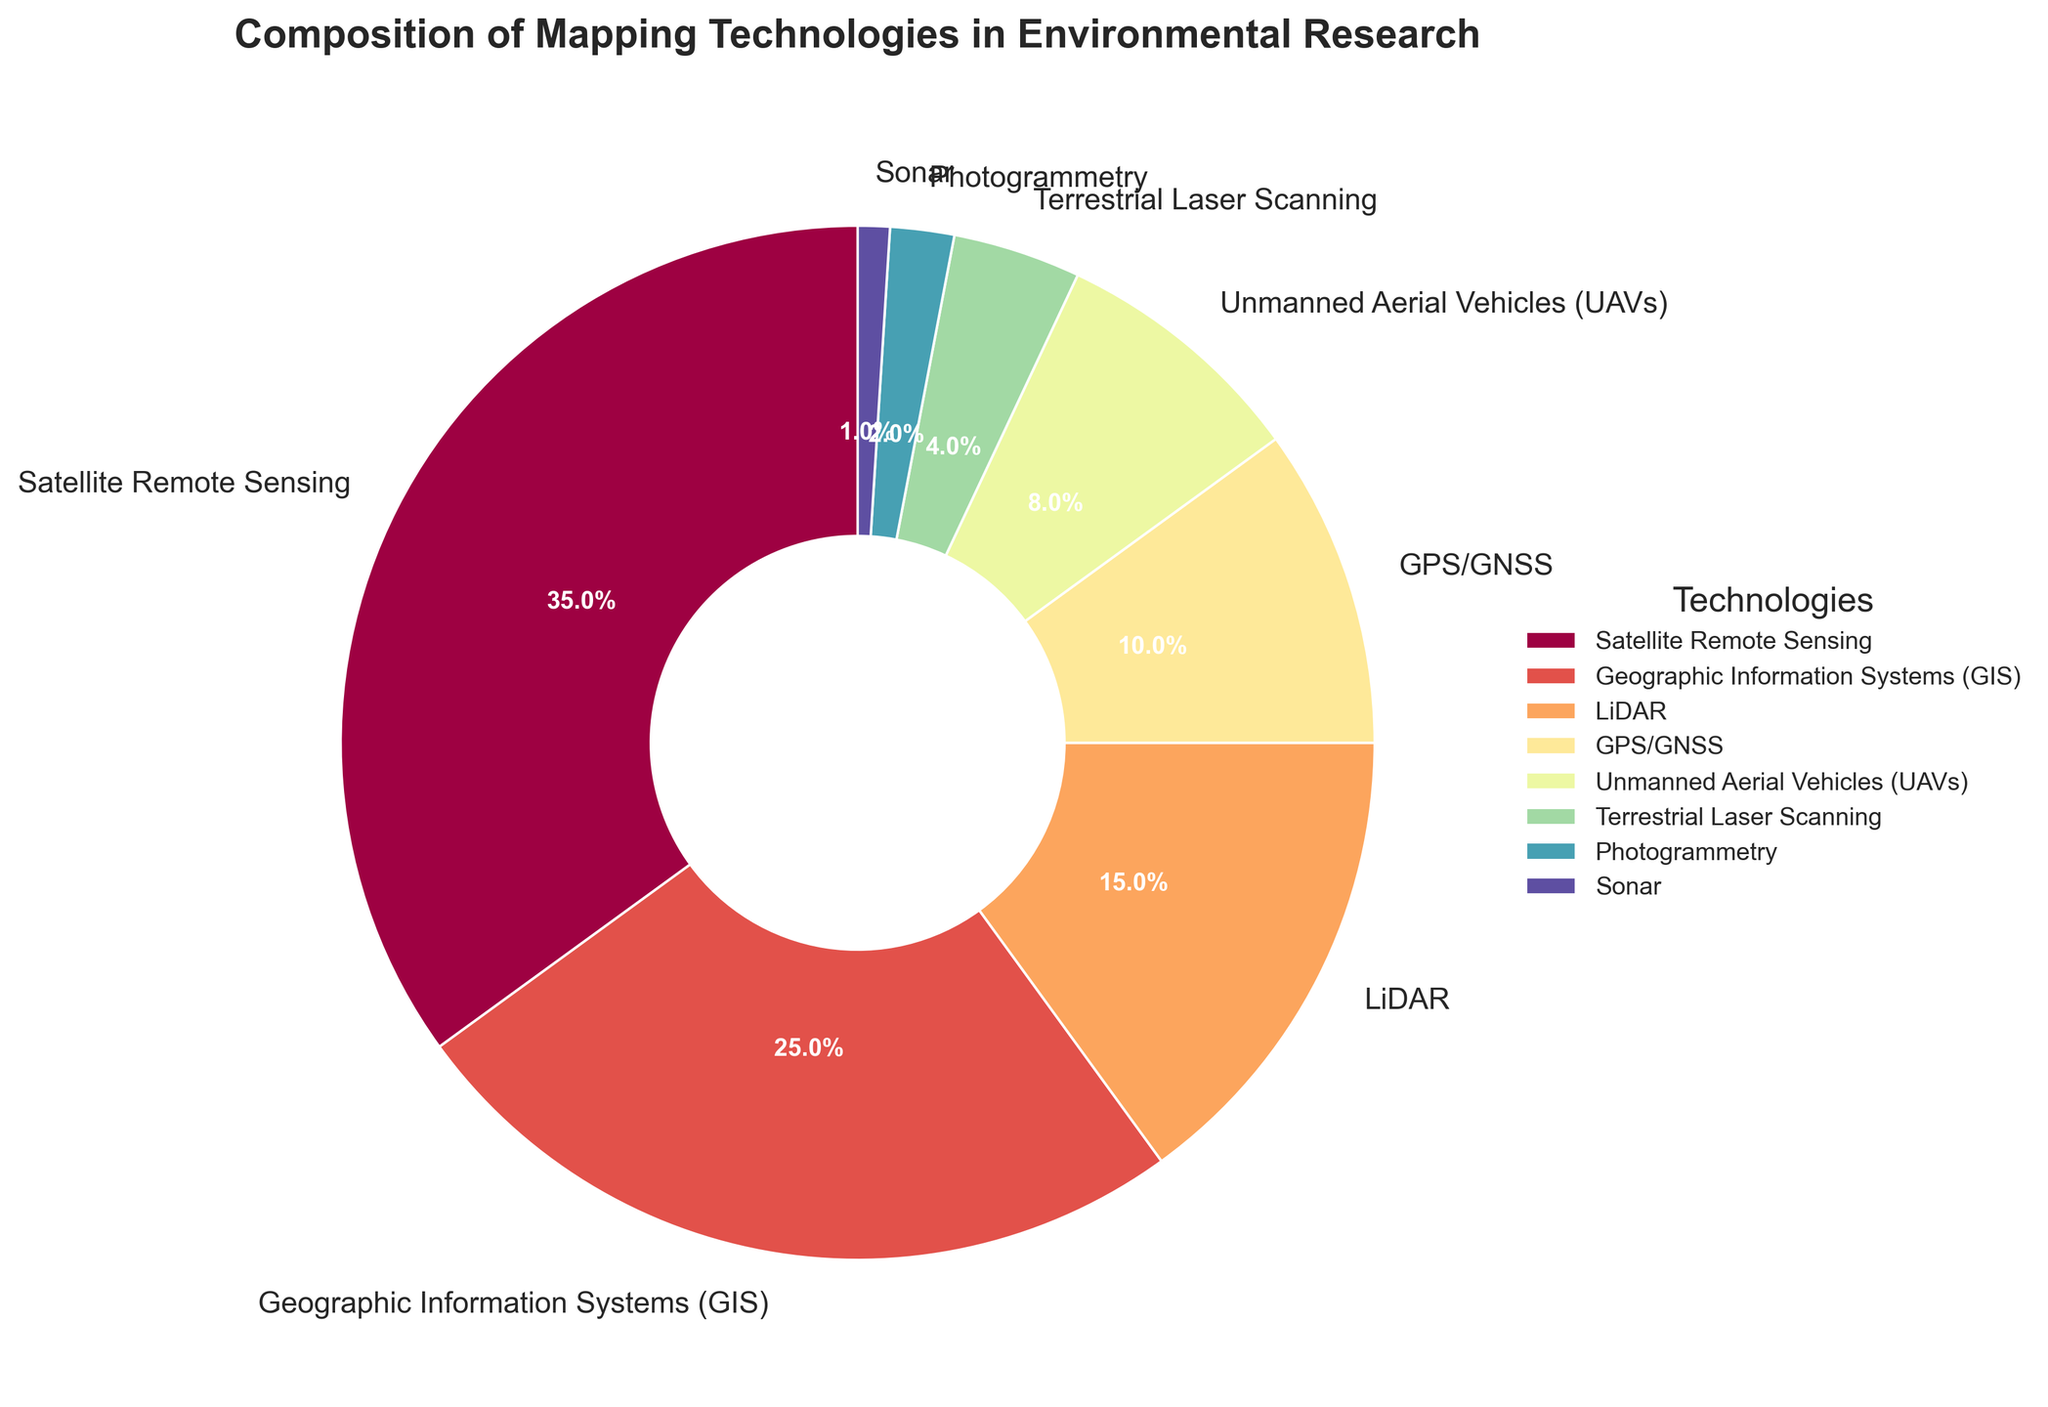What's the sum of the percentages of Satellite Remote Sensing and GIS? The chart shows Satellite Remote Sensing at 35% and GIS at 25%. Adding these together: 35% + 25% = 60%.
Answer: 60% Which technology represents the smallest percentage of usage? The chart indicates that Sonar is the technology with the smallest percentage of usage at 1%.
Answer: Sonar How much larger is the usage percentage of LiDAR compared to UAVs? LiDAR is at 15% and UAVs are at 8%. Subtracting these gives: 15% - 8% = 7%.
Answer: 7% Is the usage of GPS/GNSS greater than the combined usage of Terrestrial Laser Scanning and Photogrammetry? GPS/GNSS usage is 10%. Terrestrial Laser Scanning is 4% and Photogrammetry is 2%, so their combined usage is: 4% + 2% = 6%. Since 10% > 6%, GPS/GNSS usage is indeed greater.
Answer: Yes What's the difference between the highest and the lowest percentages in the chart? The highest percentage is for Satellite Remote Sensing at 35%, and the lowest is for Sonar at 1%. The difference is: 35% - 1% = 34%.
Answer: 34% What is the average percentage of the three least used technologies? The three least used technologies are Sonar (1%), Photogrammetry (2%), and Terrestrial Laser Scanning (4%). Their average is calculated as: (1% + 2% + 4%) / 3 = 7% / 3 ≈ 2.33%.
Answer: ~2.33% Do GIS and LiDAR combined make up more than 30% of the technologies used? GIS usage is 25% and LiDAR is 15%. Their combined usage is: 25% + 15% = 40%, which is more than 30%.
Answer: Yes Which technology has a percentage closest to the median percentage value of all the technologies shown? The percentages are sorted as follows: 1%, 2%, 4%, 8%, 10%, 15%, 25%, 35%. The median value (middle value of the sorted list) is the average of the 4th and 5th values: (8% + 10%) / 2 = 18%/2 = 9%. The closest technology percentage to 9% is GPS/GNSS at 10%.
Answer: GPS/GNSS Among the technologies displayed, which one has the second-highest usage and what is its percentage? The second-highest percentage is for GIS at 25%, following Satellite Remote Sensing at 35%.
Answer: GIS, 25% 